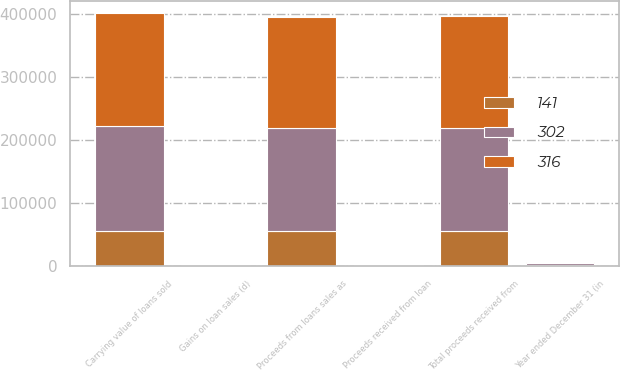Convert chart to OTSL. <chart><loc_0><loc_0><loc_500><loc_500><stacked_bar_chart><ecel><fcel>Year ended December 31 (in<fcel>Carrying value of loans sold<fcel>Proceeds received from loan<fcel>Proceeds from loans sales as<fcel>Total proceeds received from<fcel>Gains on loan sales (d)<nl><fcel>141<fcel>2014<fcel>55802<fcel>260<fcel>55117<fcel>55377<fcel>316<nl><fcel>302<fcel>2013<fcel>166028<fcel>782<fcel>163373<fcel>164155<fcel>302<nl><fcel>316<fcel>2012<fcel>179008<fcel>195<fcel>176592<fcel>176787<fcel>141<nl></chart> 